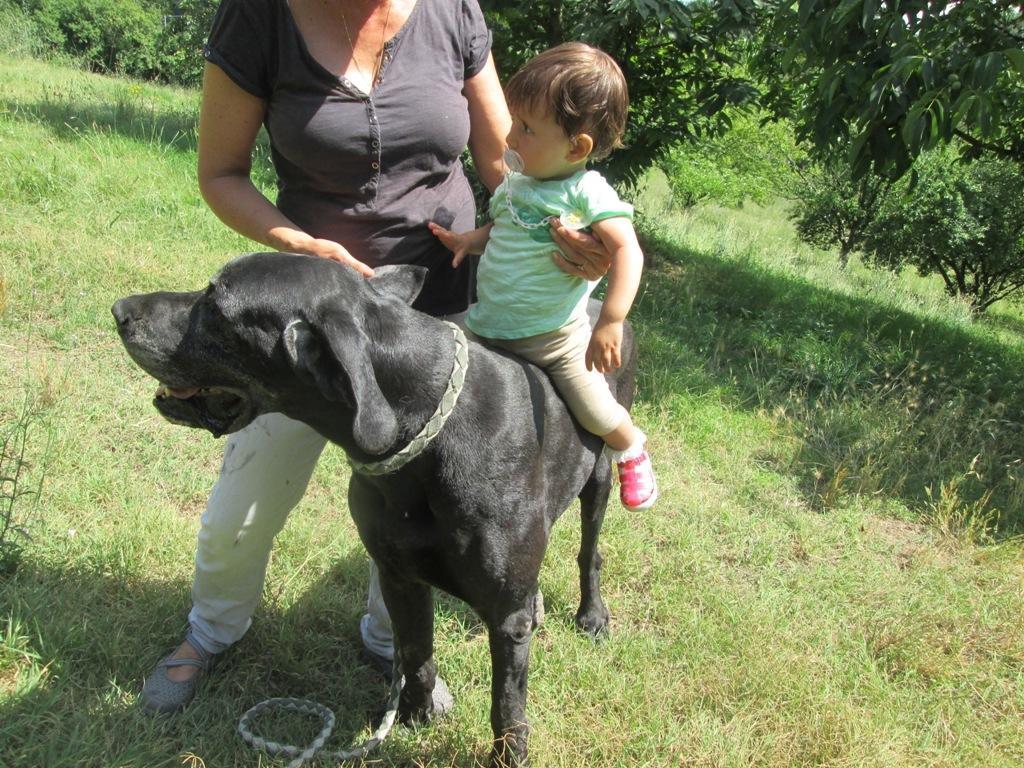In one or two sentences, can you explain what this image depicts? As we can see in the image there are trees, grass and two persons. This child is sitting on black color dog. 